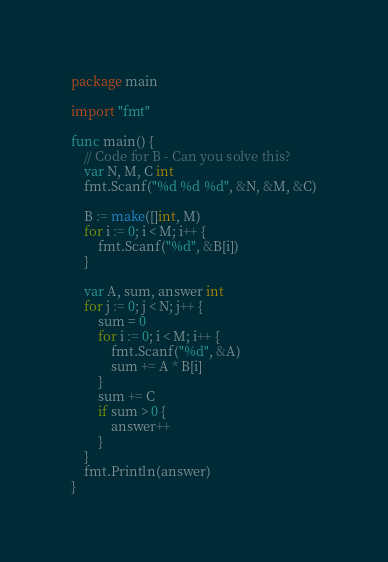Convert code to text. <code><loc_0><loc_0><loc_500><loc_500><_Go_>package main

import "fmt"

func main() {
	// Code for B - Can you solve this?
	var N, M, C int
	fmt.Scanf("%d %d %d", &N, &M, &C)

	B := make([]int, M)
	for i := 0; i < M; i++ {
		fmt.Scanf("%d", &B[i])
	}

	var A, sum, answer int
	for j := 0; j < N; j++ {
		sum = 0
		for i := 0; i < M; i++ {
			fmt.Scanf("%d", &A)
			sum += A * B[i]
		}
		sum += C
		if sum > 0 {
			answer++
		}
	}
	fmt.Println(answer)
}
</code> 